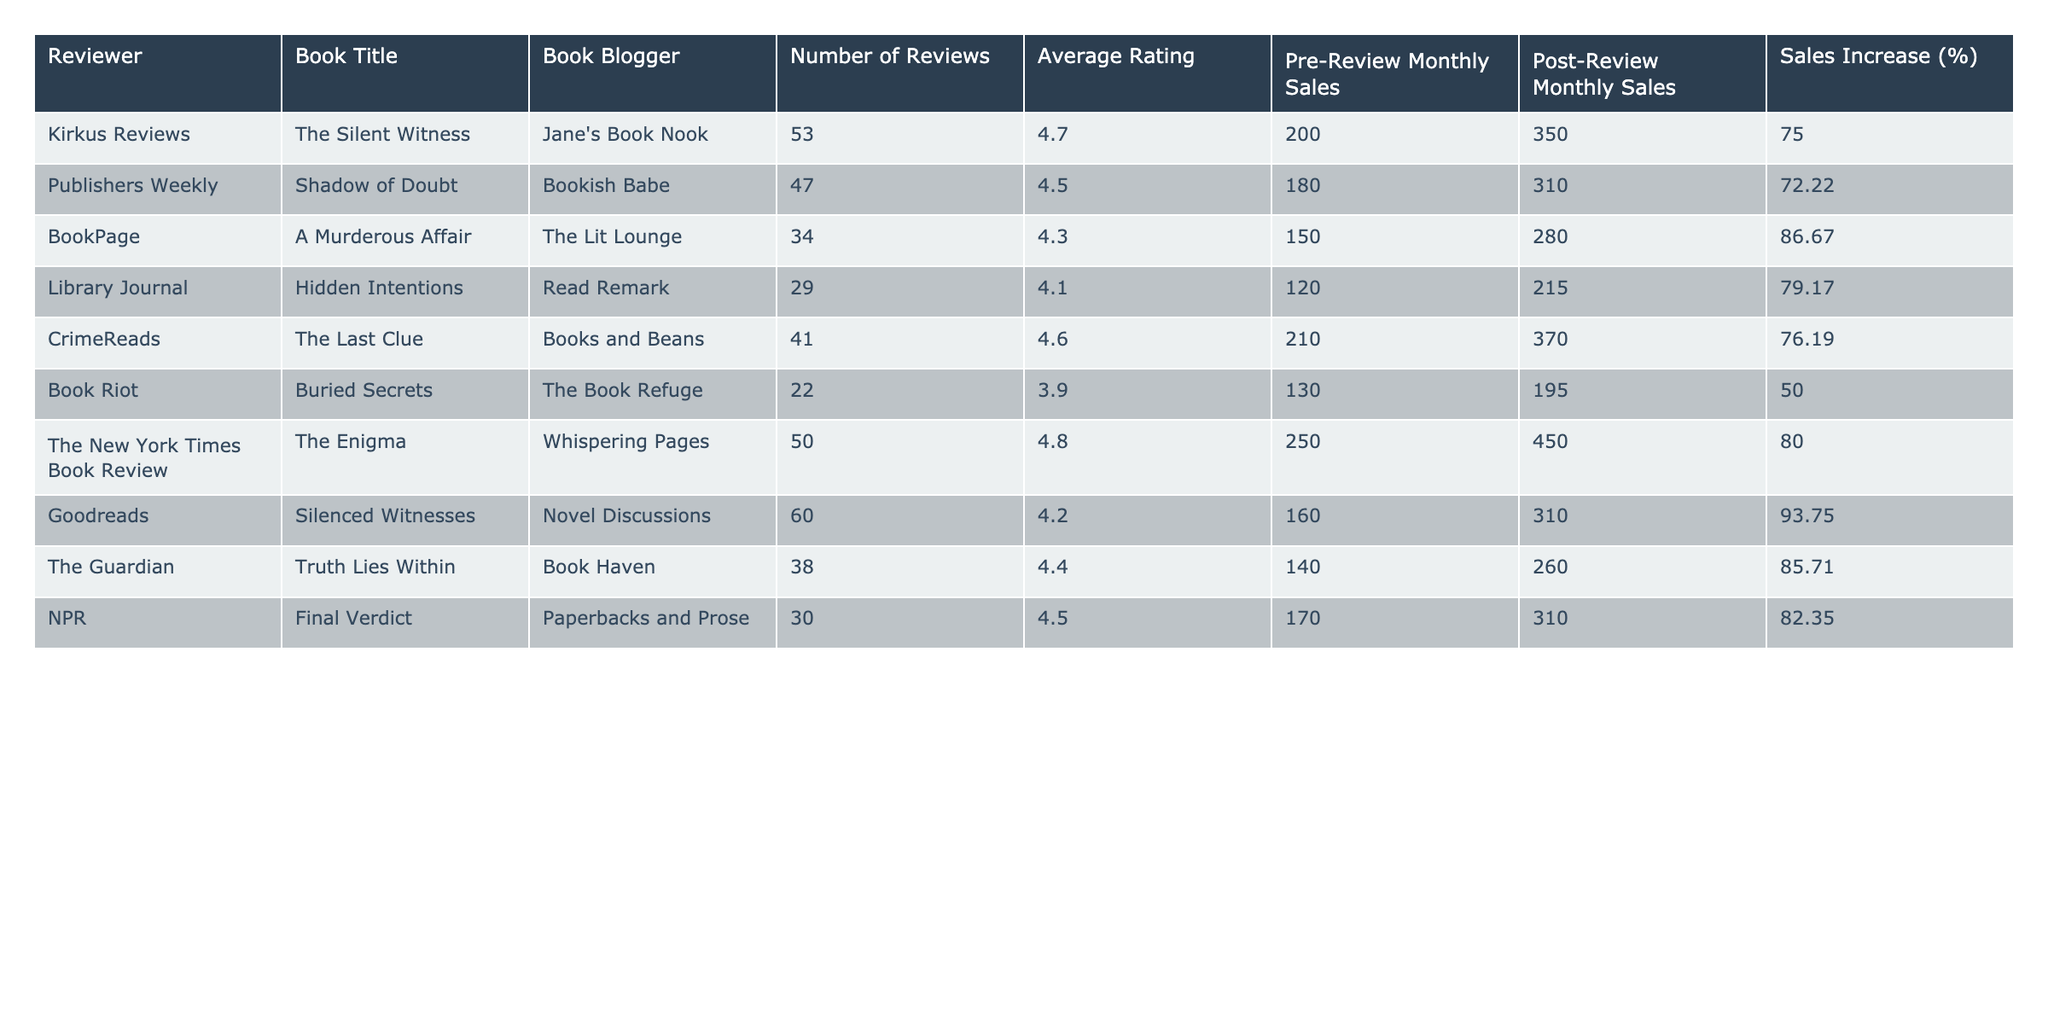what is the highest post-review monthly sales figure? The highest post-review monthly sales figure is found by looking through the "Post-Review Monthly Sales" column. The maximum value in that column is 450, attributed to "The Enigma" reviewed by "Whispering Pages."
Answer: 450 which book had the lowest average rating? To find the book with the lowest average rating, we need to check the "Average Rating" column and identify the minimum value. The lowest average rating is 3.9 for the book "Buried Secrets."
Answer: Buried Secrets how many books had sales increases of over 80%? We can count the entries in the "Sales Increase (%)" column that are greater than 80. These books are "A Murderous Affair" (86.67%), "The Enigma" (80%), and "Silenced Witnesses" (93.75%). This yields a total of three books.
Answer: 3 what is the difference between pre-review monthly sales for "The Last Clue" and "Buried Secrets"? To find the difference, we look up "The Last Clue" which has pre-review sales of 210 and "Buried Secrets" which has pre-review sales of 130. The difference is calculated as 210 - 130 = 80.
Answer: 80 did any reviewer achieve a sales increase of exactly 75%? We will check the "Sales Increase (%)" column for an entry that exactly equals 75%. The entry for "The Silent Witness" shows a sales increase of 75%. Therefore, the answer is yes.
Answer: Yes which book's reviewer had the highest number of reviews? We look for the maximum number in the "Number of Reviews" column. The maximum is 60 reviews for "Silenced Witnesses" reviewed by "Novel Discussions."
Answer: Silenced Witnesses what is the average sales increase percentage for the books reviewed by "Book Haven"? There is only one book reviewed by "Book Haven," which is "Truth Lies Within," with a sales increase of 85.71%. Thus, the average sales increase for books reviewed by "Book Haven" is also 85.71%.
Answer: 85.71 what is the median of the average ratings? To find the median, we must list the average ratings in order: 3.9, 4.1, 4.2, 4.3, 4.4, 4.5, 4.6, 4.7, 4.8. The median will be the middle value. There are nine ratings, so the median is the fifth value, which is 4.4.
Answer: 4.4 how many reviewers had an average rating of 4.5 or higher? Count the entries in the "Average Rating" that are 4.5 or above. The ratings above this threshold are 4.7, 4.5, 4.6, 4.8, 4.5, and 4.4, giving a total of six reviewers.
Answer: 6 